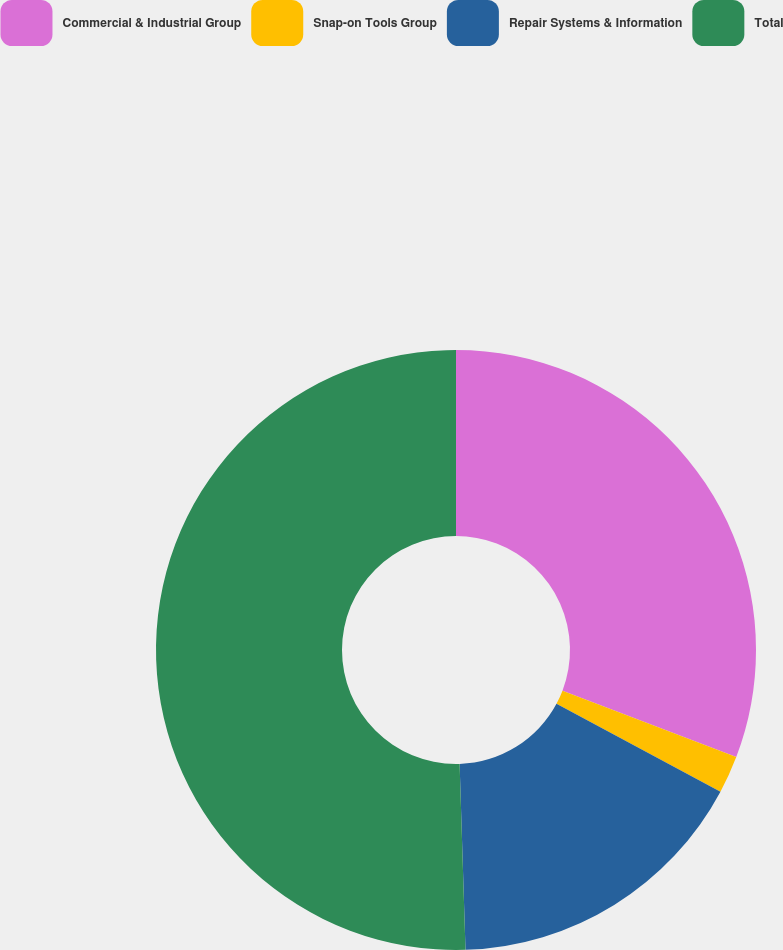Convert chart. <chart><loc_0><loc_0><loc_500><loc_500><pie_chart><fcel>Commercial & Industrial Group<fcel>Snap-on Tools Group<fcel>Repair Systems & Information<fcel>Total<nl><fcel>30.81%<fcel>2.02%<fcel>16.67%<fcel>50.51%<nl></chart> 